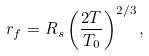<formula> <loc_0><loc_0><loc_500><loc_500>r _ { f } = R _ { s } \left ( \frac { 2 T } { T _ { 0 } } \right ) ^ { 2 / 3 } ,</formula> 